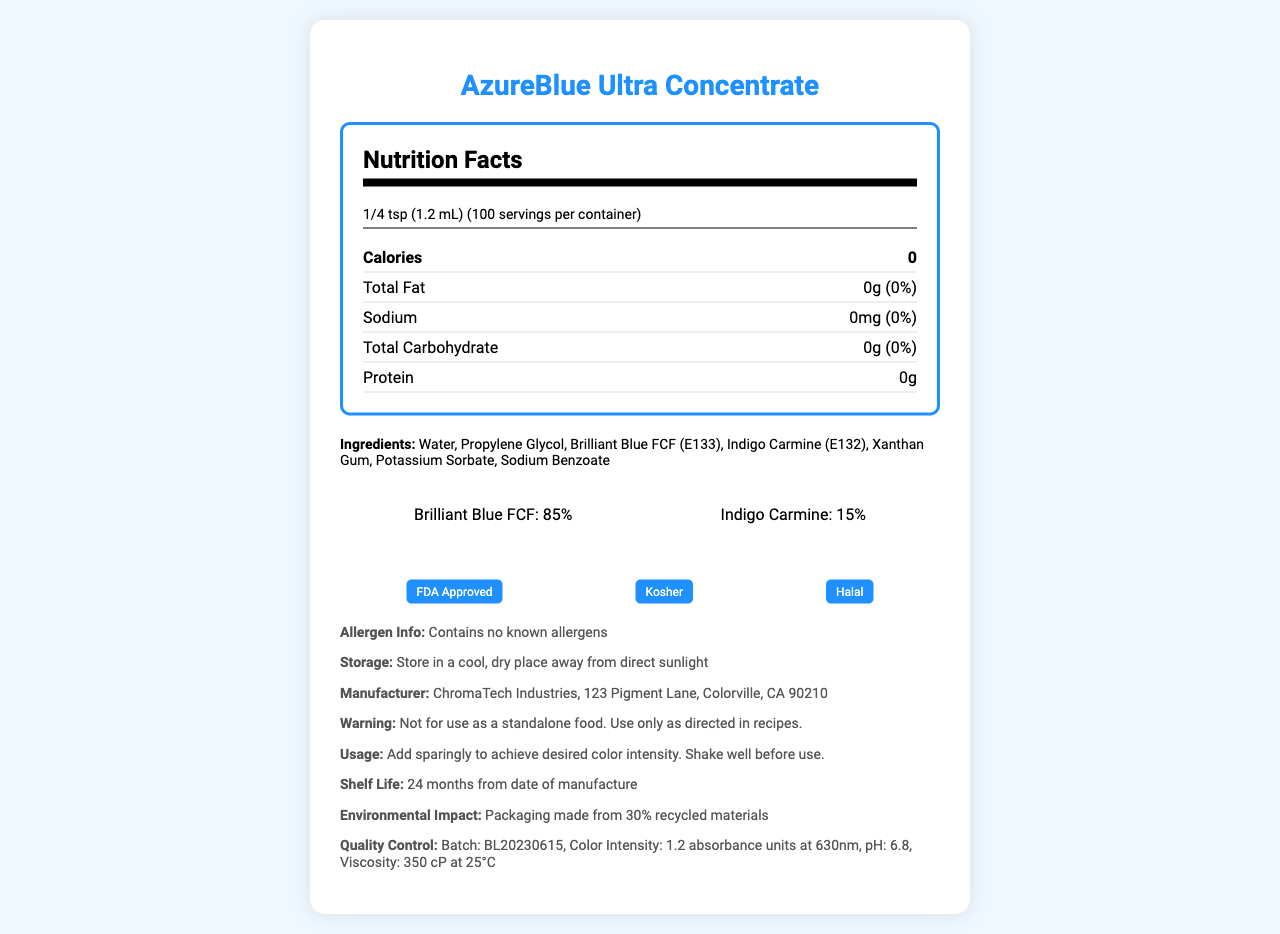what is the serving size for AzureBlue Ultra Concentrate? The document specifies the serving size directly under the Nutrition Facts title.
Answer: 1/4 tsp (1.2 mL) how many servings are there in one container? This information is listed immediately after the serving size under the Nutrition Facts title.
Answer: 100 servings how many calories are in one serving of AzureBlue Ultra Concentrate? The row under the Nutrition Facts section marked "Calories" indicates the amount per serving is 0.
Answer: 0 calories what are the two primary pigments in AzureBlue Ultra Concentrate and their proportions? The pigment composition section shows a breakdown of Brilliant Blue FCF at 85% and Indigo Carmine at 15%.
Answer: Brilliant Blue FCF (85%) and Indigo Carmine (15%) who is the manufacturer of AzureBlue Ultra Concentrate? The manufacturer information section lists ChromaTech Industries as the manufacturer.
Answer: ChromaTech Industries which of the following ingredients is not in AzureBlue Ultra Concentrate? A. Water B. Brilliant Blue FCF C. Citrus Extract The ingredients list includes Water and Brilliant Blue FCF, but not Citrus Extract.
Answer: C. Citrus Extract what is the shelf life of AzureBlue Ultra Concentrate? The shelf life information is provided in the usage instructions section of the document.
Answer: 24 months from date of manufacture is AzureBlue Ultra Concentrate suitable for a Kosher diet? The certifications section indicates that the product is Kosher.
Answer: Yes does AzureBlue Ultra Concentrate contain any known allergens? The allergen information section clearly states that it contains no known allergens.
Answer: No how should AzureBlue Ultra Concentrate be stored? The storage instructions section provides these specific details.
Answer: Store in a cool, dry place away from direct sunlight what is the color intensity of AzureBlue Ultra Concentrate as per the quality control measures? The quality control section specifies the color intensity measurement.
Answer: 1.2 absorbance units at 630nm what is the pH value of AzureBlue Ultra Concentrate? This information can be found under the quality control section.
Answer: 6.8 what should you do before using AzureBlue Ultra Concentrate? A. Shake well B. Freeze it C. Heat it The usage instructions mention shaking well before use to achieve the desired color intensity.
Answer: A. Shake well how much propylene glycol is in AzureBlue Ultra Concentrate? The document lists Propylene Glycol as an ingredient but does not provide its quantity.
Answer: Not enough information summarize the main information provided in the document. In summary, the document gives a comprehensive overview of the AzureBlue Ultra Concentrate product, including nutritional facts, ingredients, and handling instructions.
Answer: The document provides nutritional facts and other key details about AzureBlue Ultra Concentrate, a blue food coloring. It lists the serving size, servings per container, calorie content, and other nutritional details like fat, sodium, carbohydrate, and protein content. The document also includes ingredients, pigment composition, allergen information, storage instructions, manufacturer details, certifications, usage instructions, shelf life, and quality control measures. 